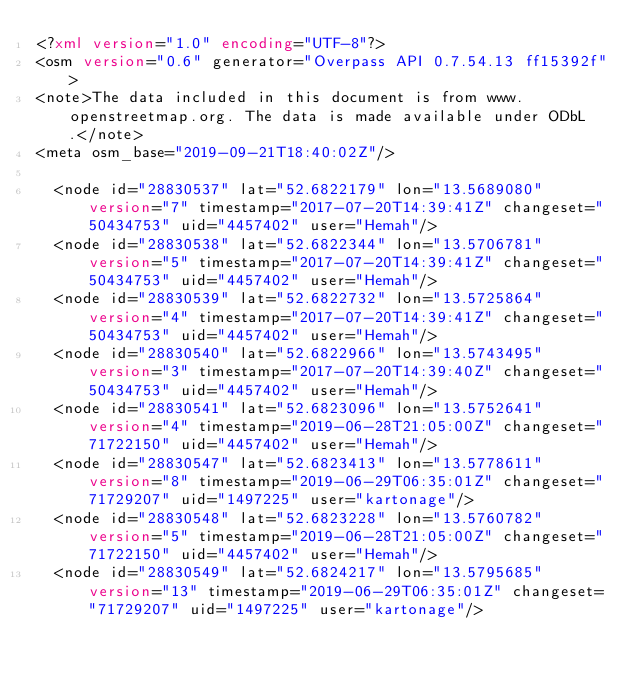<code> <loc_0><loc_0><loc_500><loc_500><_XML_><?xml version="1.0" encoding="UTF-8"?>
<osm version="0.6" generator="Overpass API 0.7.54.13 ff15392f">
<note>The data included in this document is from www.openstreetmap.org. The data is made available under ODbL.</note>
<meta osm_base="2019-09-21T18:40:02Z"/>

  <node id="28830537" lat="52.6822179" lon="13.5689080" version="7" timestamp="2017-07-20T14:39:41Z" changeset="50434753" uid="4457402" user="Hemah"/>
  <node id="28830538" lat="52.6822344" lon="13.5706781" version="5" timestamp="2017-07-20T14:39:41Z" changeset="50434753" uid="4457402" user="Hemah"/>
  <node id="28830539" lat="52.6822732" lon="13.5725864" version="4" timestamp="2017-07-20T14:39:41Z" changeset="50434753" uid="4457402" user="Hemah"/>
  <node id="28830540" lat="52.6822966" lon="13.5743495" version="3" timestamp="2017-07-20T14:39:40Z" changeset="50434753" uid="4457402" user="Hemah"/>
  <node id="28830541" lat="52.6823096" lon="13.5752641" version="4" timestamp="2019-06-28T21:05:00Z" changeset="71722150" uid="4457402" user="Hemah"/>
  <node id="28830547" lat="52.6823413" lon="13.5778611" version="8" timestamp="2019-06-29T06:35:01Z" changeset="71729207" uid="1497225" user="kartonage"/>
  <node id="28830548" lat="52.6823228" lon="13.5760782" version="5" timestamp="2019-06-28T21:05:00Z" changeset="71722150" uid="4457402" user="Hemah"/>
  <node id="28830549" lat="52.6824217" lon="13.5795685" version="13" timestamp="2019-06-29T06:35:01Z" changeset="71729207" uid="1497225" user="kartonage"/></code> 